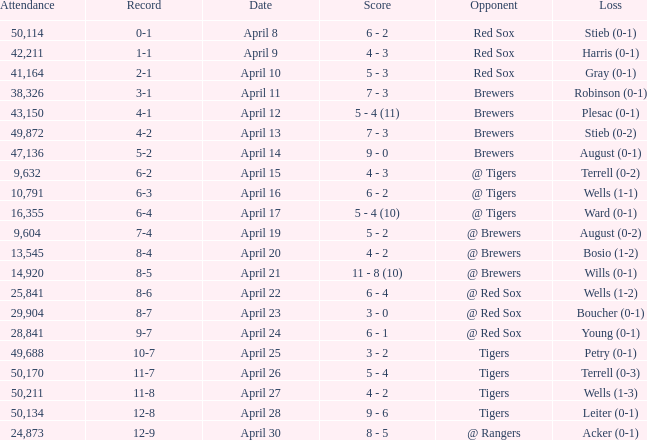Which loss has an attendance greater than 49,688 and 11-8 as the record? Wells (1-3). 